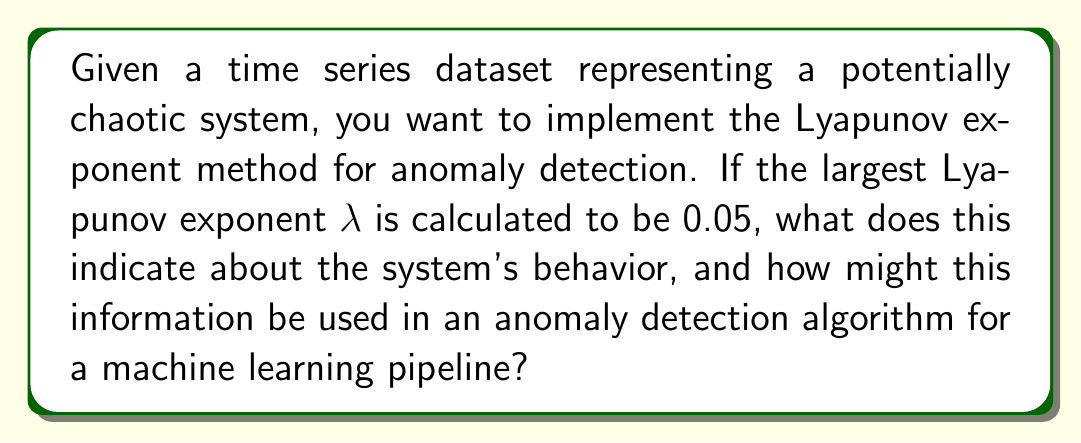Solve this math problem. To understand the implications of the Lyapunov exponent and its use in anomaly detection, let's break this down step-by-step:

1. The Lyapunov exponent ($\lambda$) quantifies the rate of separation of infinitesimally close trajectories in a dynamical system. It's defined as:

   $$\lambda = \lim_{t \to \infty} \lim_{d_0 \to 0} \frac{1}{t} \ln \frac{d(t)}{d_0}$$

   where $d_0$ is the initial separation and $d(t)$ is the separation after time $t$.

2. The sign and magnitude of $\lambda$ indicate different system behaviors:
   - $\lambda < 0$: The system is stable (attracting fixed point or limit cycle)
   - $\lambda = 0$: The system is in equilibrium (neutrally stable)
   - $\lambda > 0$: The system exhibits chaotic behavior

3. In this case, $\lambda = 0.05 > 0$, which indicates that the system is chaotic.

4. For chaotic systems, nearby trajectories diverge exponentially over time. The rate of divergence is approximately:

   $$d(t) \approx d_0 e^{\lambda t}$$

5. This chaotic behavior can be leveraged for anomaly detection in a machine learning pipeline:

   a. Establish a baseline: Use the Lyapunov exponent to characterize the "normal" chaotic behavior of the system.
   
   b. Sliding window analysis: Compute $\lambda$ for sliding windows of the time series data.
   
   c. Anomaly threshold: Define a threshold for deviation from the baseline $\lambda$.
   
   d. Flag anomalies: If the computed $\lambda$ for a window significantly deviates from the baseline, flag it as a potential anomaly.

6. Implementation in a machine learning pipeline:
   - Preprocess the time series data
   - Compute Lyapunov exponents using libraries like nolds or PyDynamic
   - Use the computed $\lambda$ values as features for an anomaly detection model (e.g., Isolation Forest or One-Class SVM)
   - Train the model on "normal" data and use it to detect anomalies in new data

7. Advantages of this approach:
   - Captures complex, non-linear dynamics in the data
   - Can detect subtle changes in system behavior that might not be apparent with traditional statistical methods
   - Suitable for real-time monitoring and anomaly detection in streaming data
Answer: The system is chaotic ($\lambda > 0$); use as feature in ML anomaly detection pipeline 